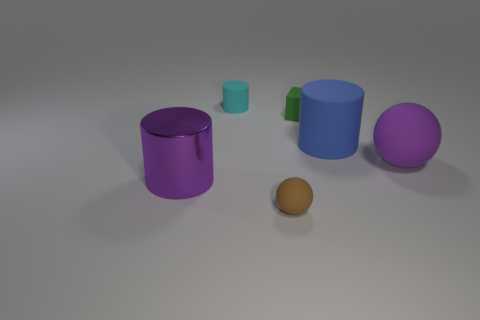What is the texture of the objects in the image? All objects in the image appear to have a smooth and reflective texture, which gives them a shiny appearance under the lighting conditions. 